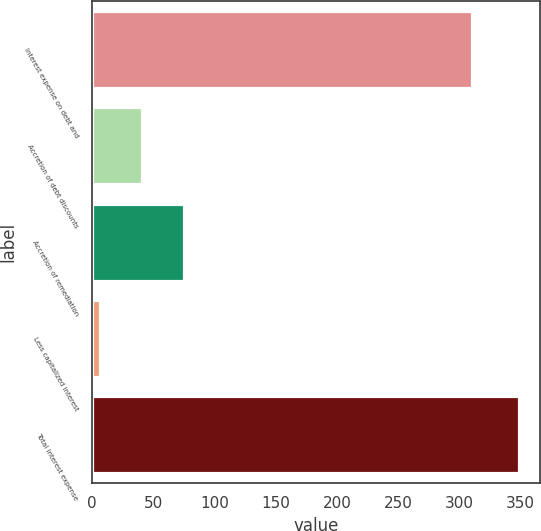<chart> <loc_0><loc_0><loc_500><loc_500><bar_chart><fcel>Interest expense on debt and<fcel>Accretion of debt discounts<fcel>Accretion of remediation<fcel>Less capitalized interest<fcel>Total interest expense<nl><fcel>310.3<fcel>40.63<fcel>74.86<fcel>6.4<fcel>348.7<nl></chart> 